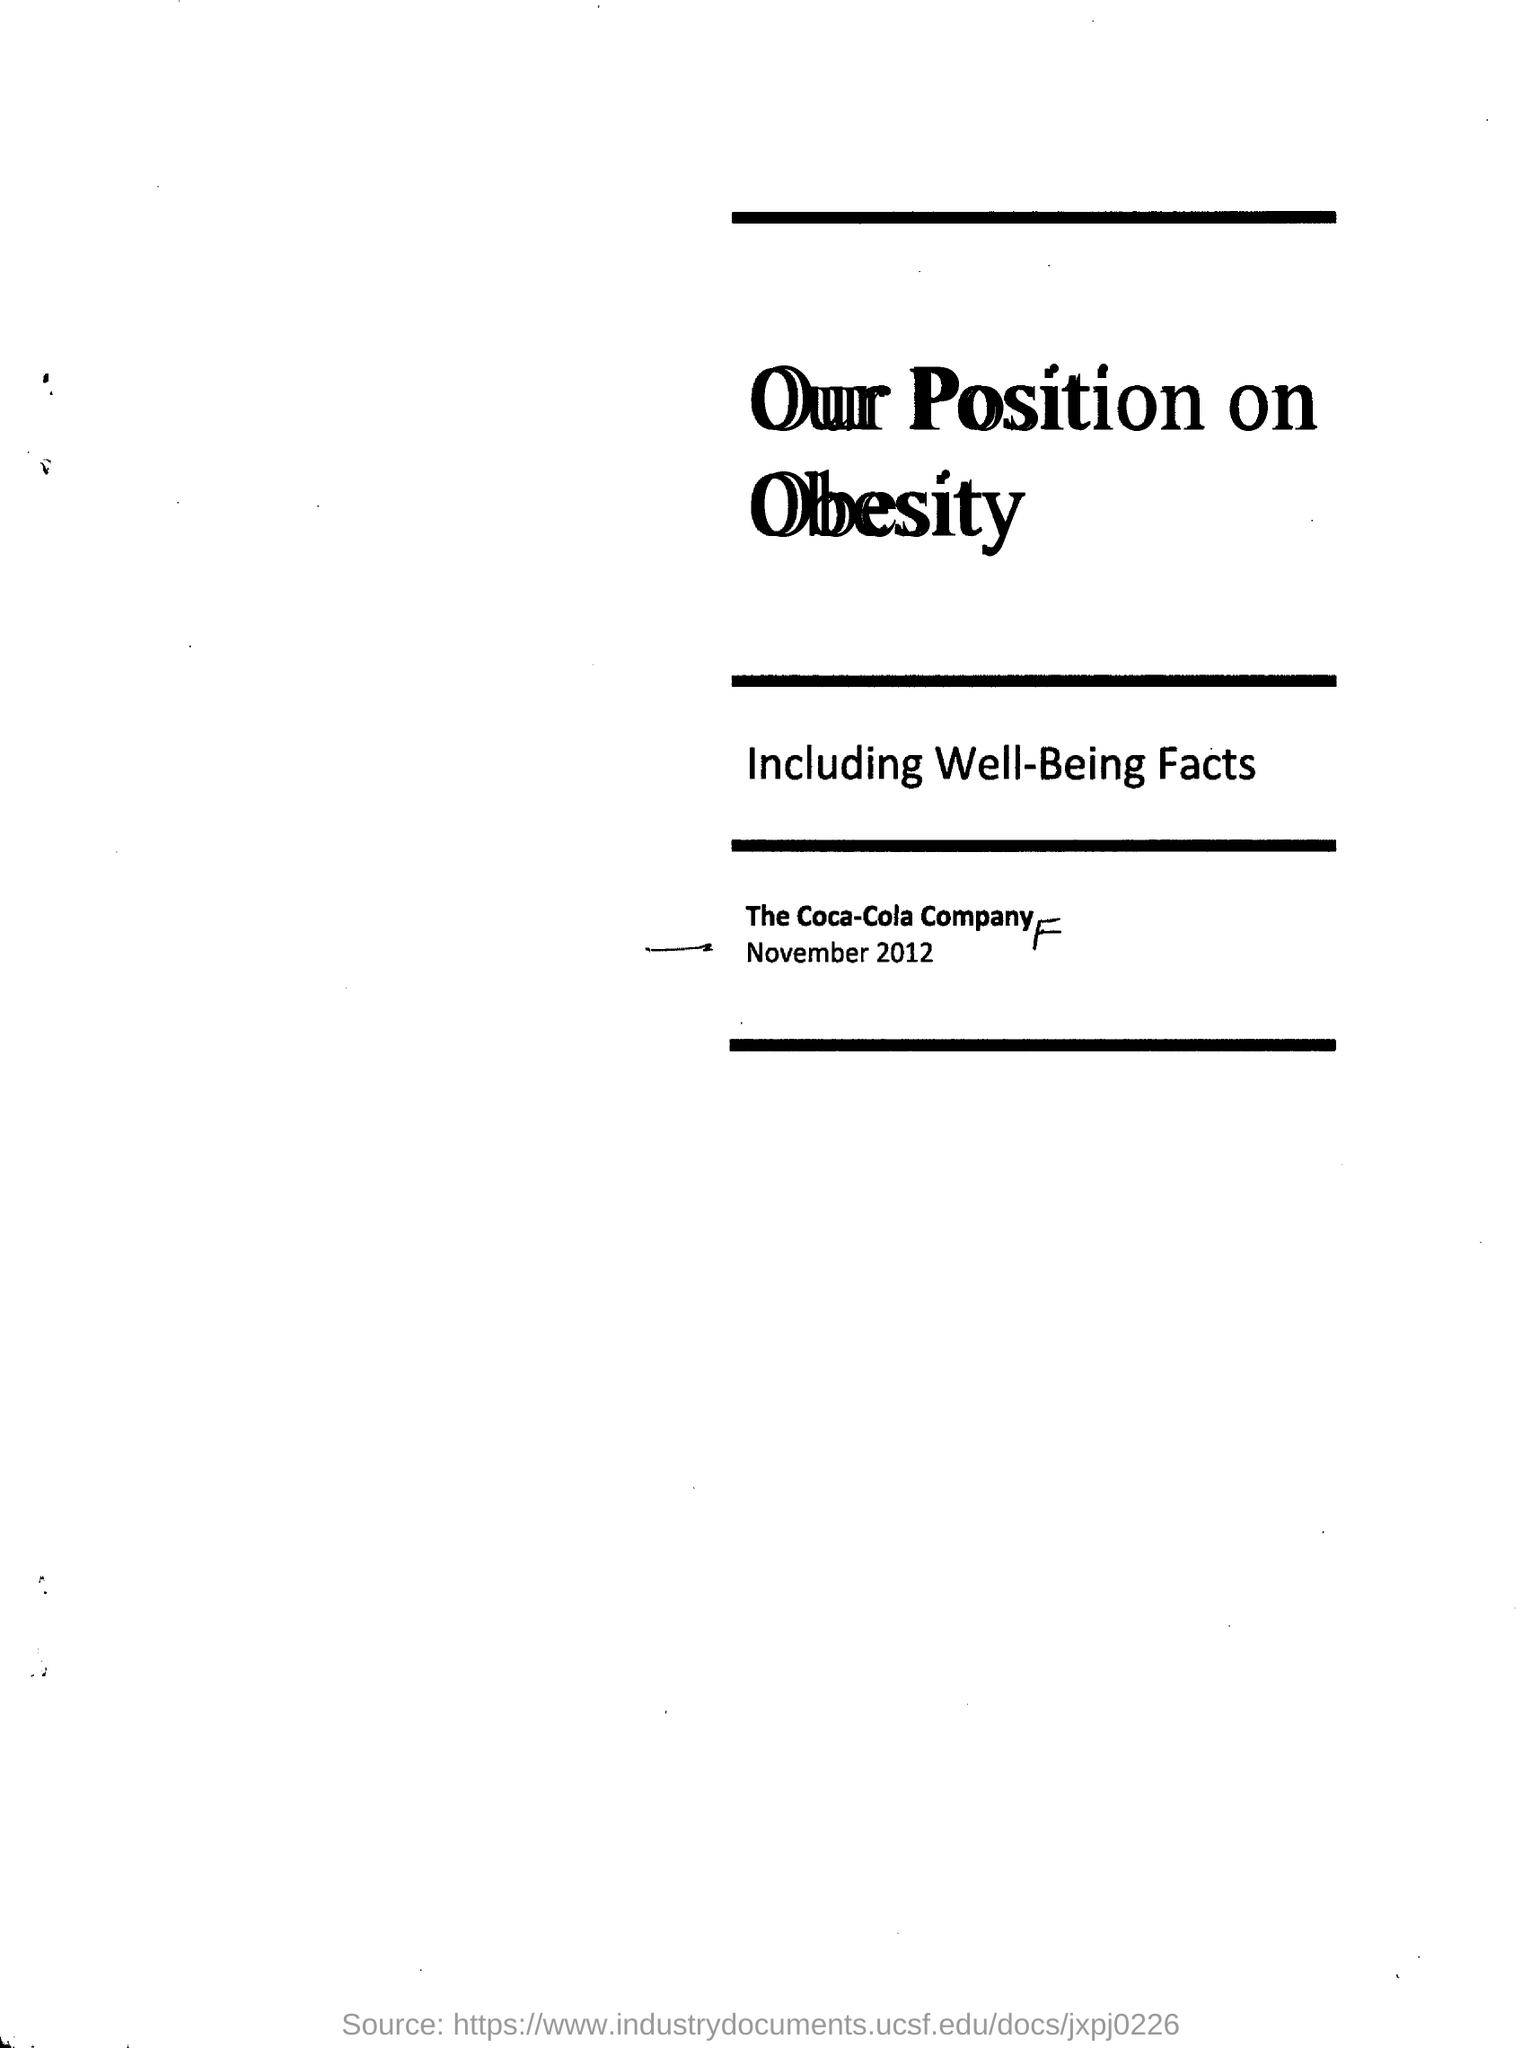What is the name of the company mentioned in the document?
Give a very brief answer. The Coca-Cola Company. 